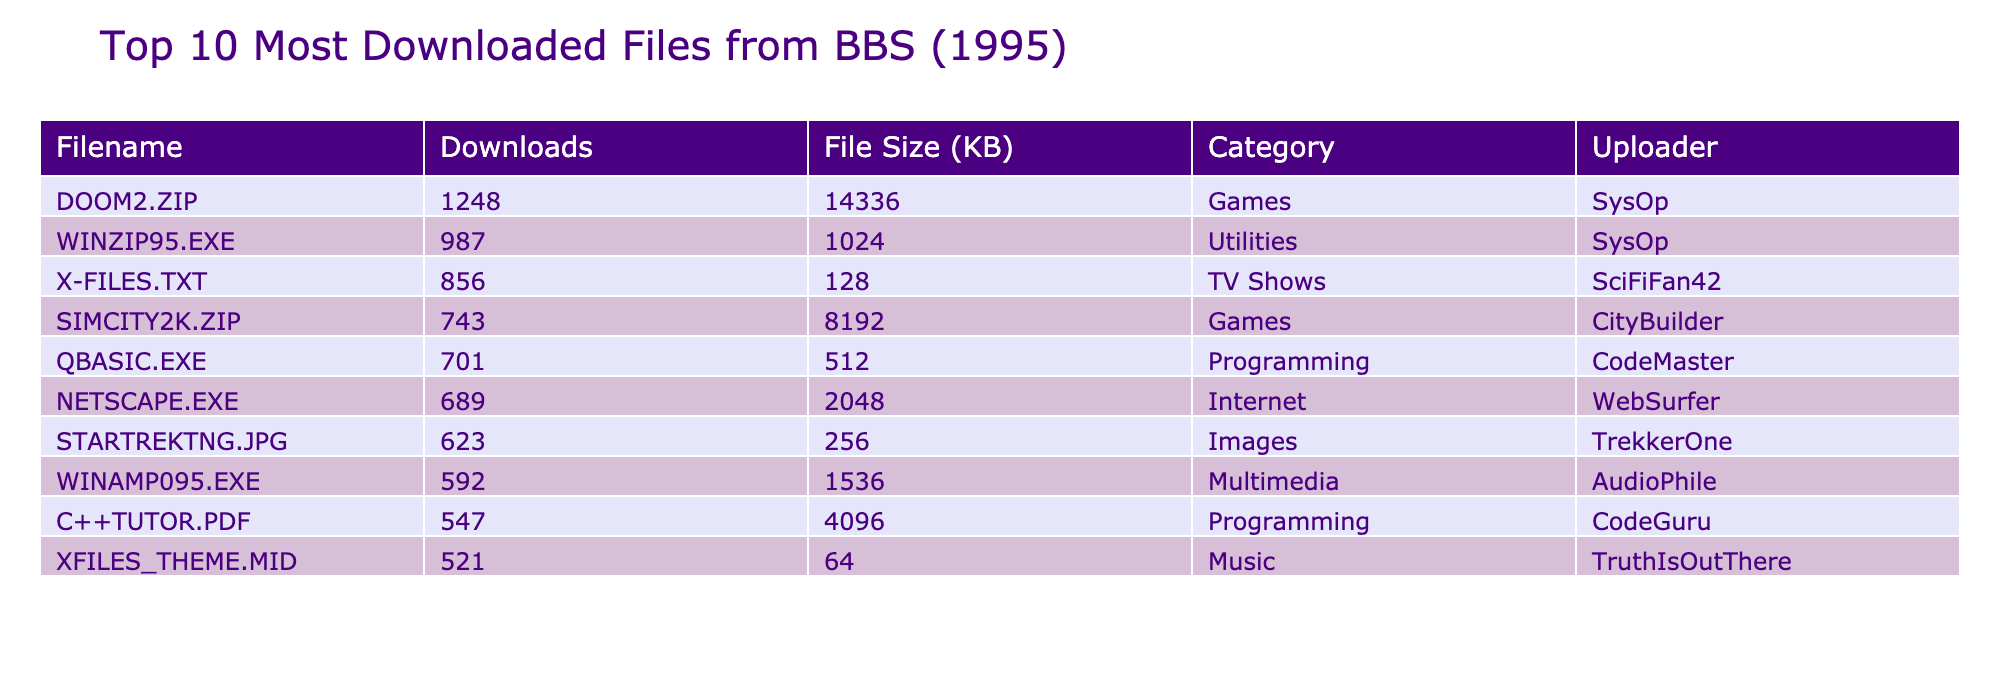What is the most downloaded file in the table? The most downloaded file can be found in the "Downloads" column by looking for the highest number. The top entry is DOOM2.ZIP with 1248 downloads.
Answer: DOOM2.ZIP Which category does WINZIP95.EXE belong to? The category of WINZIP95.EXE is listed in the "Category" column next to its entry. It is categorized as "Utilities".
Answer: Utilities What is the total number of downloads for all games listed? To find the total downloads for the games, we sum the downloads for DOOM2.ZIP (1248) and SIMCITY2K.ZIP (743). Adding them together gives us 1248 + 743 = 1991.
Answer: 1991 Is there a file with the highest file size? To determine if there is a file with the highest file size, we can compare the "File Size (KB)" values in the table. The largest is 14336 KB for DOOM2.ZIP, therefore yes, there is a file with a highest size.
Answer: Yes What is the average file size of the files in the Programming category? The Programming category includes QBASIC.EXE (512 KB) and C++TUTOR.PDF (4096 KB). To find the average, sum these sizes: 512 + 4096 = 4608 KB, then divide by the number of files (2): 4608 / 2 = 2304 KB.
Answer: 2304 KB Which uploader has the most files in the table? We need to count the number of entries for each uploader. SysOp has 2 files (DOOM2.ZIP, WINZIP95.EXE), while others have only 1 each. Therefore, SysOp has the most files.
Answer: SysOp How many downloads does the least downloaded file have? The least downloaded file can be identified by looking for the smallest number in the "Downloads" column. The file XFILES_THEME.MID has 521 downloads, which is the lowest in the table.
Answer: 521 What is the difference in downloads between the file with the most downloads and the file with the least downloads? The file with the most downloads is DOOM2.ZIP with 1248 downloads, and the file with the least is XFILES_THEME.MID with 521 downloads. The difference is 1248 - 521 = 727.
Answer: 727 Do any of the files have the same number of downloads? We can look through the "Downloads" column to see if there are any duplicate entries. In this case, all the files have unique download numbers, so the answer is no.
Answer: No 